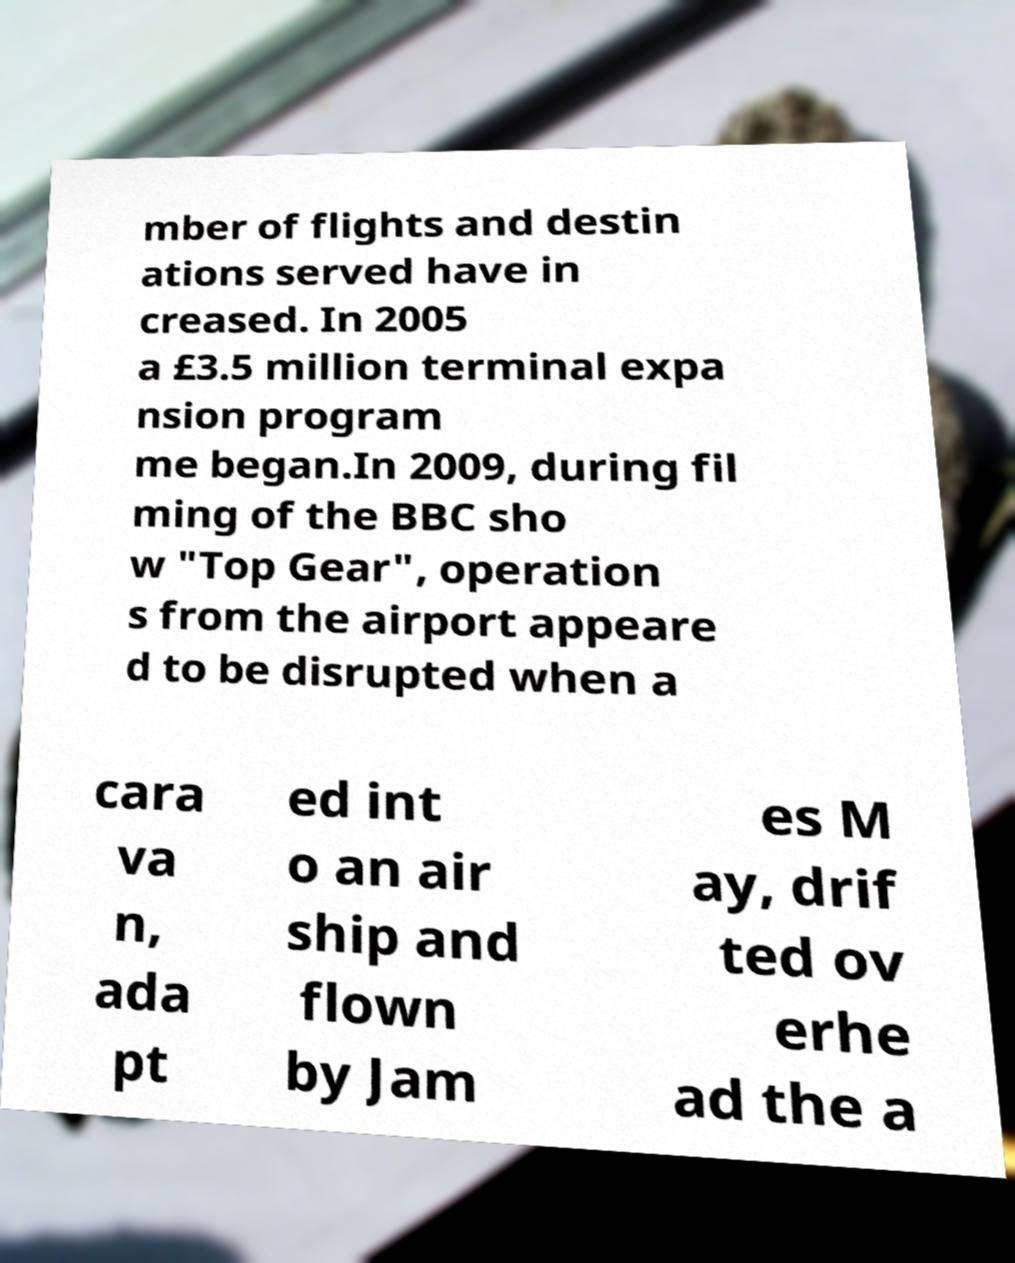Please read and relay the text visible in this image. What does it say? mber of flights and destin ations served have in creased. In 2005 a £3.5 million terminal expa nsion program me began.In 2009, during fil ming of the BBC sho w "Top Gear", operation s from the airport appeare d to be disrupted when a cara va n, ada pt ed int o an air ship and flown by Jam es M ay, drif ted ov erhe ad the a 